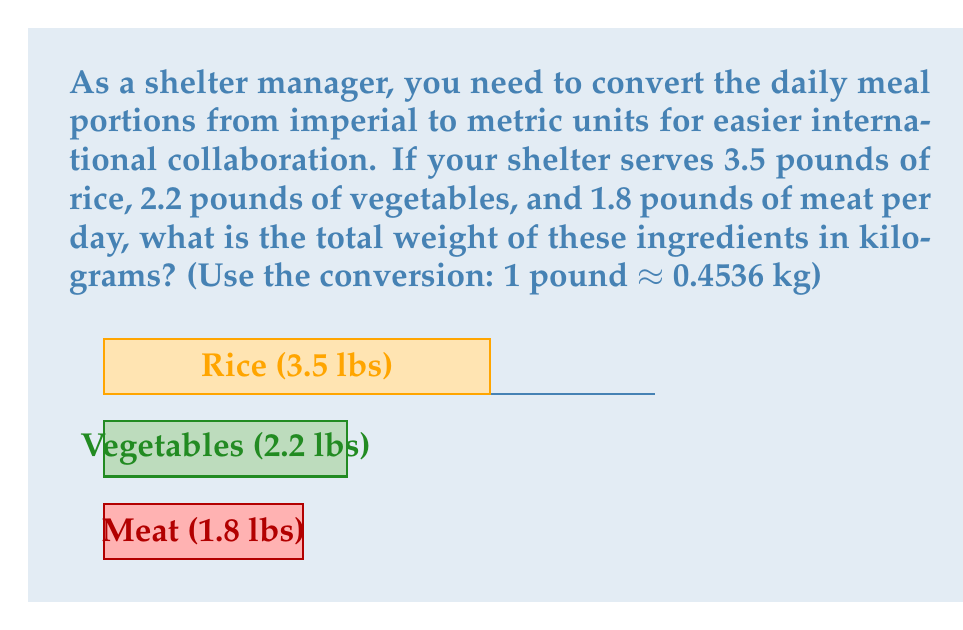What is the answer to this math problem? To solve this problem, we need to:
1. Convert each ingredient from pounds to kilograms
2. Sum up the converted weights

Let's go through it step-by-step:

1. Converting pounds to kilograms:
   We use the formula: $\text{weight in kg} = \text{weight in lbs} \times 0.4536$

   Rice: $3.5 \text{ lbs} \times 0.4536 = 1.5876 \text{ kg}$
   Vegetables: $2.2 \text{ lbs} \times 0.4536 = 0.99792 \text{ kg}$
   Meat: $1.8 \text{ lbs} \times 0.4536 = 0.81648 \text{ kg}$

2. Summing up the converted weights:
   $$\text{Total weight} = 1.5876 + 0.99792 + 0.81648 = 3.402 \text{ kg}$$

Therefore, the total weight of the daily meal portions in kilograms is approximately 3.402 kg.
Answer: 3.402 kg 